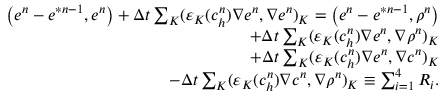<formula> <loc_0><loc_0><loc_500><loc_500>\begin{array} { r } { \left ( e ^ { n } - e ^ { \ast n - 1 } , e ^ { n } \right ) + \Delta t \sum _ { K } ( \varepsilon _ { K } ( c _ { h } ^ { n } ) \nabla e ^ { n } , \nabla e ^ { n } ) _ { K } = \left ( e ^ { n } - e ^ { \ast n - 1 } , \rho ^ { n } \right ) } \\ { + \Delta t \sum _ { K } ( \varepsilon _ { K } ( c _ { h } ^ { n } ) \nabla e ^ { n } , \nabla \rho ^ { n } ) _ { K } } \\ { + \Delta t \sum _ { K } ( \varepsilon _ { K } ( c _ { h } ^ { n } ) \nabla e ^ { n } , \nabla c ^ { n } ) _ { K } } \\ { - \Delta t \sum _ { K } ( \varepsilon _ { K } ( c _ { h } ^ { n } ) \nabla c ^ { n } , \nabla \rho ^ { n } ) _ { K } \equiv \sum _ { i = 1 } ^ { 4 } R _ { i } . } \end{array}</formula> 